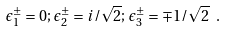Convert formula to latex. <formula><loc_0><loc_0><loc_500><loc_500>\epsilon ^ { \pm } _ { 1 } = 0 ; \, \epsilon ^ { \pm } _ { 2 } = i / \sqrt { 2 } ; \, \epsilon ^ { \pm } _ { 3 } = \mp 1 / \sqrt { 2 } \ .</formula> 